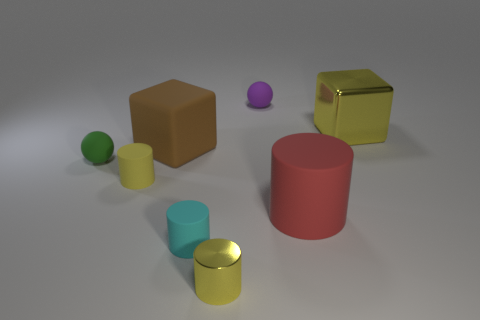Is the number of tiny rubber things that are right of the yellow block the same as the number of big rubber cubes that are right of the cyan matte thing?
Your response must be concise. Yes. Do the matte object behind the yellow shiny block and the metallic object behind the yellow metal cylinder have the same shape?
Keep it short and to the point. No. What is the shape of the small green thing that is the same material as the small cyan cylinder?
Ensure brevity in your answer.  Sphere. Is the number of cyan cylinders that are right of the tiny yellow shiny thing the same as the number of small gray cubes?
Offer a very short reply. Yes. Does the yellow cylinder in front of the tiny cyan cylinder have the same material as the yellow object on the left side of the matte cube?
Give a very brief answer. No. There is a yellow object that is on the right side of the object behind the large yellow shiny cube; what is its shape?
Offer a terse response. Cube. What color is the other big object that is made of the same material as the big red thing?
Your answer should be very brief. Brown. Does the big metallic cube have the same color as the tiny shiny object?
Keep it short and to the point. Yes. There is a green matte thing that is the same size as the yellow metallic cylinder; what shape is it?
Provide a succinct answer. Sphere. The green sphere is what size?
Your answer should be compact. Small. 